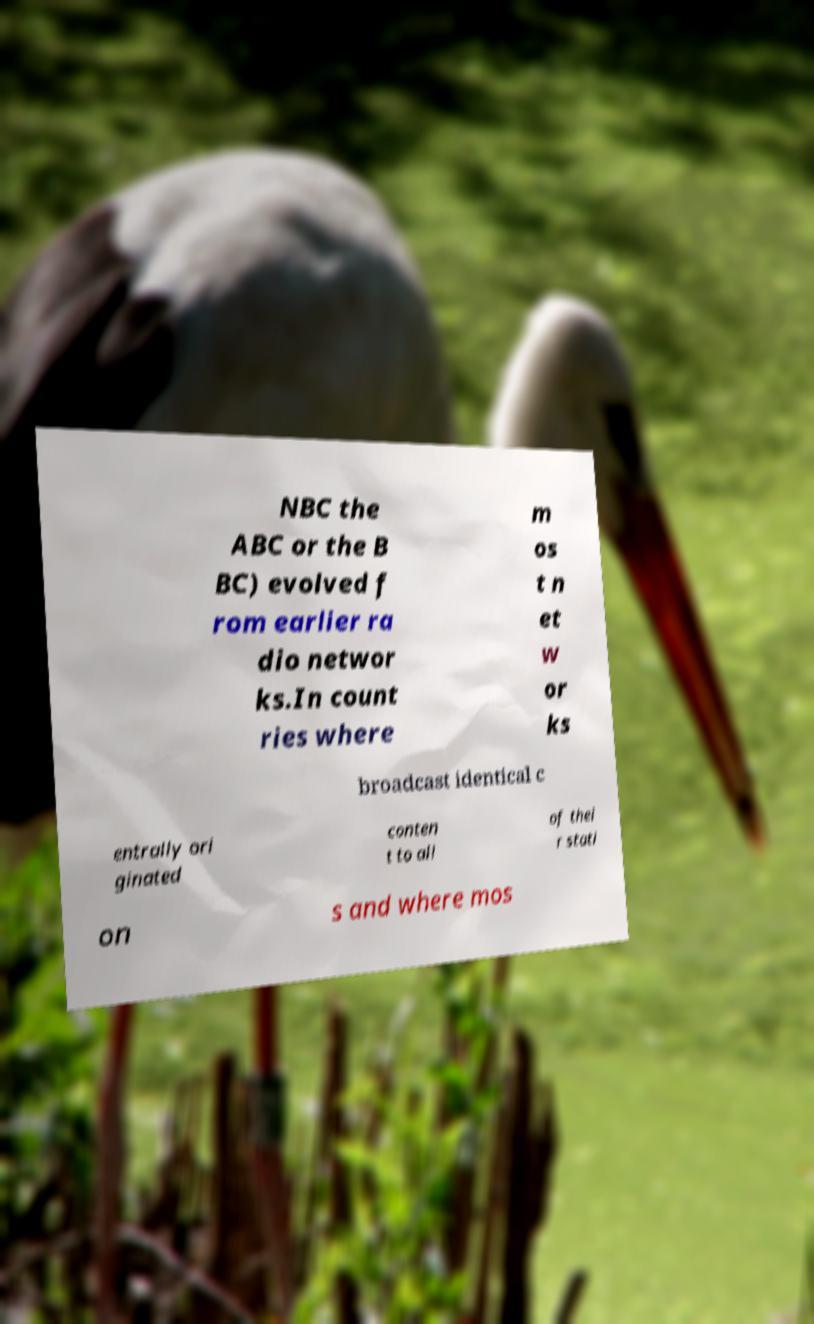Could you extract and type out the text from this image? NBC the ABC or the B BC) evolved f rom earlier ra dio networ ks.In count ries where m os t n et w or ks broadcast identical c entrally ori ginated conten t to all of thei r stati on s and where mos 